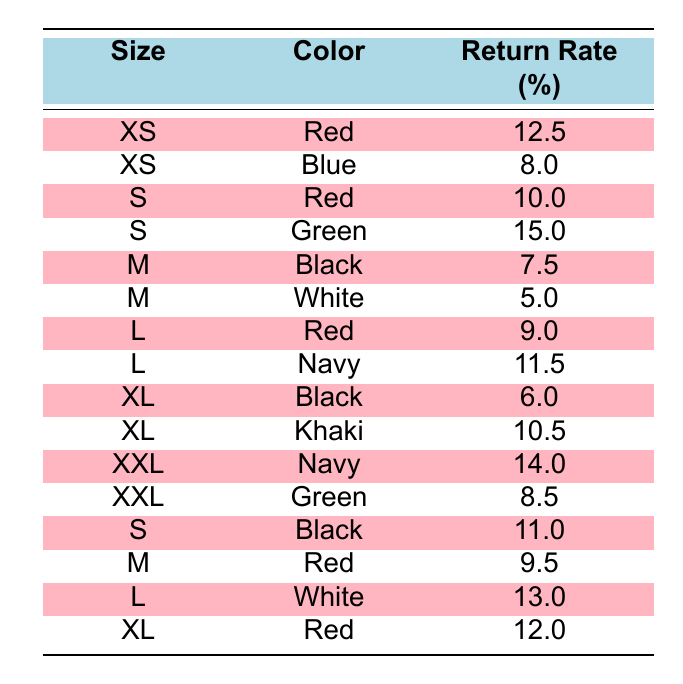What is the return rate for size M in color Black? The return rate for size M in color Black is directly found in the table, where it states this particular return rate is 7.5.
Answer: 7.5 Which color has the highest return rate for size S? For size S, the data shows two colors: Red with a return rate of 10.0 and Green with a return rate of 15.0. Comparing these, Green has the highest return rate.
Answer: Green What is the difference in return rates between size L in color Red and size L in color White? The return rate for size L in color Red is 9.0, while for White it is 13.0. The difference is calculated as 13.0 - 9.0 = 4.0.
Answer: 4.0 Is the return rate for size XL in color Khaki greater than that for size M in color White? The return rate for size XL in color Khaki is 10.5 and for size M in White it is 5.0. Since 10.5 is greater than 5.0, the answer is yes.
Answer: Yes What is the average return rate for size XXL across both colors? The return rates for size XXL are 14.0 for Navy and 8.5 for Green. To find the average, sum these two rates: 14.0 + 8.5 = 22.5, and then divide by 2 (22.5 / 2 = 11.25).
Answer: 11.25 What is the highest return rate in size L? The table shows the return rates for size L in Red (9.0) and White (13.0) and Navy (11.5). The highest among these three is 13.0 for White.
Answer: 13.0 Are there more colors with a return rate of 10% or above for size M than for size S? For size M, the colors Black (7.5), White (5.0), and Red (9.5) do not exceed 10%, meaning there are no colors above 10%. For size S, the color Red (10.0) and Green (15.0) both exceed 10%. Therefore, size S has more.
Answer: No What is the total return rate for size XL across both colors? The return rates for size XL are 6.0 for Black and 10.5 for Khaki. Adding these together gives: 6.0 + 10.5 = 16.5.
Answer: 16.5 What size/color combination has the lowest return rate? The return rates in the table are listed, and the lowest is found in size M with color White at a return rate of 5.0.
Answer: M, White 